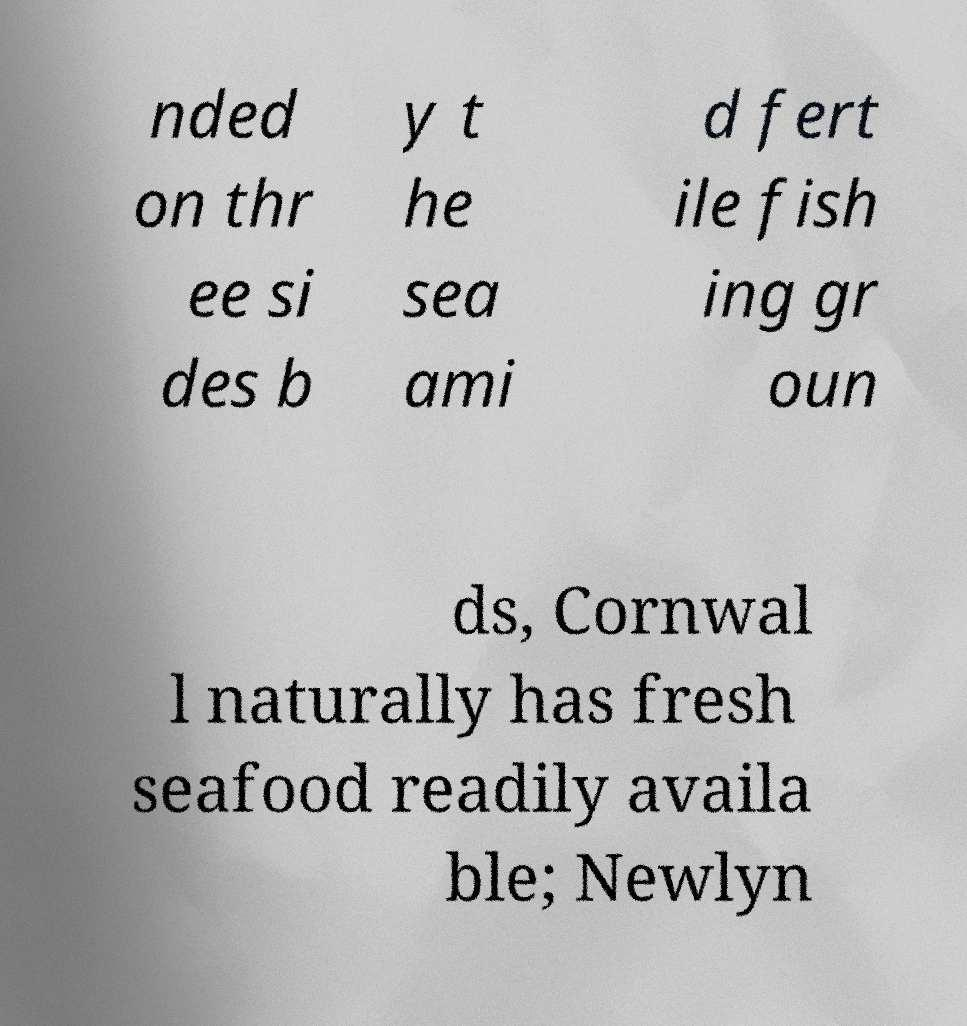For documentation purposes, I need the text within this image transcribed. Could you provide that? nded on thr ee si des b y t he sea ami d fert ile fish ing gr oun ds, Cornwal l naturally has fresh seafood readily availa ble; Newlyn 